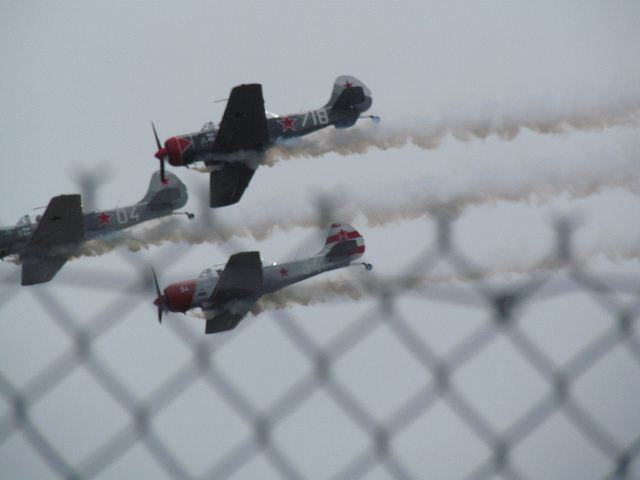Extract all visible text content from this image. 04 71B 04 